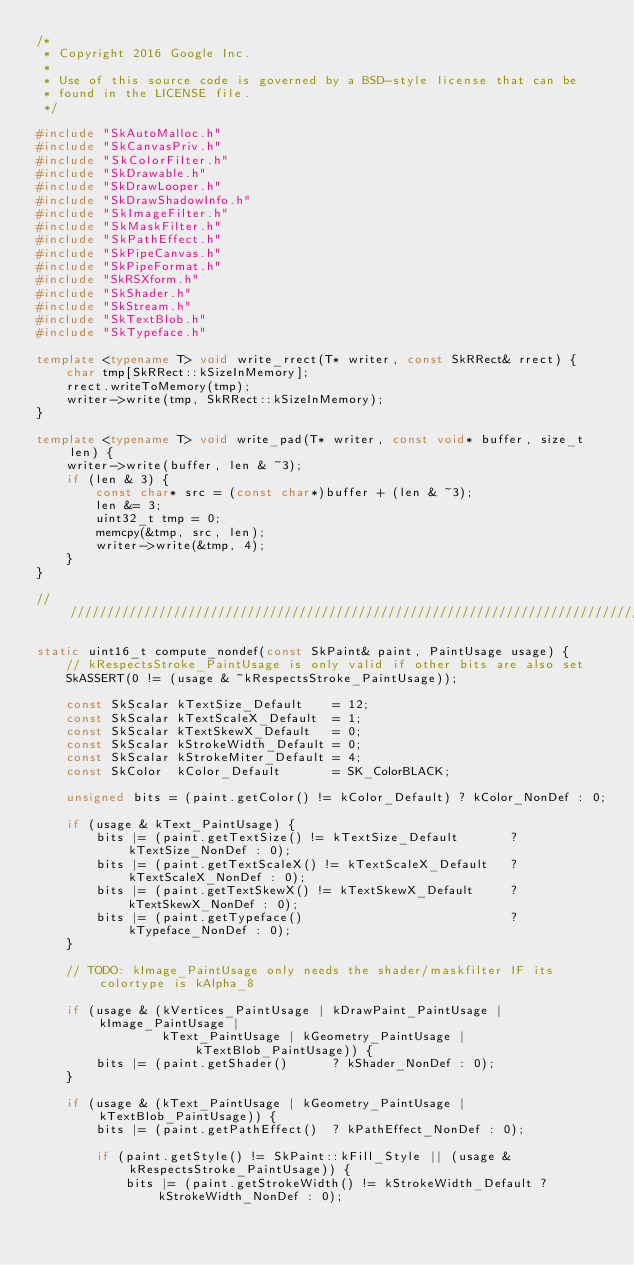<code> <loc_0><loc_0><loc_500><loc_500><_C++_>/*
 * Copyright 2016 Google Inc.
 *
 * Use of this source code is governed by a BSD-style license that can be
 * found in the LICENSE file.
 */

#include "SkAutoMalloc.h"
#include "SkCanvasPriv.h"
#include "SkColorFilter.h"
#include "SkDrawable.h"
#include "SkDrawLooper.h"
#include "SkDrawShadowInfo.h"
#include "SkImageFilter.h"
#include "SkMaskFilter.h"
#include "SkPathEffect.h"
#include "SkPipeCanvas.h"
#include "SkPipeFormat.h"
#include "SkRSXform.h"
#include "SkShader.h"
#include "SkStream.h"
#include "SkTextBlob.h"
#include "SkTypeface.h"

template <typename T> void write_rrect(T* writer, const SkRRect& rrect) {
    char tmp[SkRRect::kSizeInMemory];
    rrect.writeToMemory(tmp);
    writer->write(tmp, SkRRect::kSizeInMemory);
}

template <typename T> void write_pad(T* writer, const void* buffer, size_t len) {
    writer->write(buffer, len & ~3);
    if (len & 3) {
        const char* src = (const char*)buffer + (len & ~3);
        len &= 3;
        uint32_t tmp = 0;
        memcpy(&tmp, src, len);
        writer->write(&tmp, 4);
    }
}

///////////////////////////////////////////////////////////////////////////////////////////////////

static uint16_t compute_nondef(const SkPaint& paint, PaintUsage usage) {
    // kRespectsStroke_PaintUsage is only valid if other bits are also set
    SkASSERT(0 != (usage & ~kRespectsStroke_PaintUsage));

    const SkScalar kTextSize_Default    = 12;
    const SkScalar kTextScaleX_Default  = 1;
    const SkScalar kTextSkewX_Default   = 0;
    const SkScalar kStrokeWidth_Default = 0;
    const SkScalar kStrokeMiter_Default = 4;
    const SkColor  kColor_Default       = SK_ColorBLACK;

    unsigned bits = (paint.getColor() != kColor_Default) ? kColor_NonDef : 0;

    if (usage & kText_PaintUsage) {
        bits |= (paint.getTextSize() != kTextSize_Default       ? kTextSize_NonDef : 0);
        bits |= (paint.getTextScaleX() != kTextScaleX_Default   ? kTextScaleX_NonDef : 0);
        bits |= (paint.getTextSkewX() != kTextSkewX_Default     ? kTextSkewX_NonDef : 0);
        bits |= (paint.getTypeface()                            ? kTypeface_NonDef : 0);
    }

    // TODO: kImage_PaintUsage only needs the shader/maskfilter IF its colortype is kAlpha_8

    if (usage & (kVertices_PaintUsage | kDrawPaint_PaintUsage | kImage_PaintUsage |
                 kText_PaintUsage | kGeometry_PaintUsage | kTextBlob_PaintUsage)) {
        bits |= (paint.getShader()      ? kShader_NonDef : 0);
    }

    if (usage & (kText_PaintUsage | kGeometry_PaintUsage | kTextBlob_PaintUsage)) {
        bits |= (paint.getPathEffect()  ? kPathEffect_NonDef : 0);

        if (paint.getStyle() != SkPaint::kFill_Style || (usage & kRespectsStroke_PaintUsage)) {
            bits |= (paint.getStrokeWidth() != kStrokeWidth_Default ? kStrokeWidth_NonDef : 0);</code> 